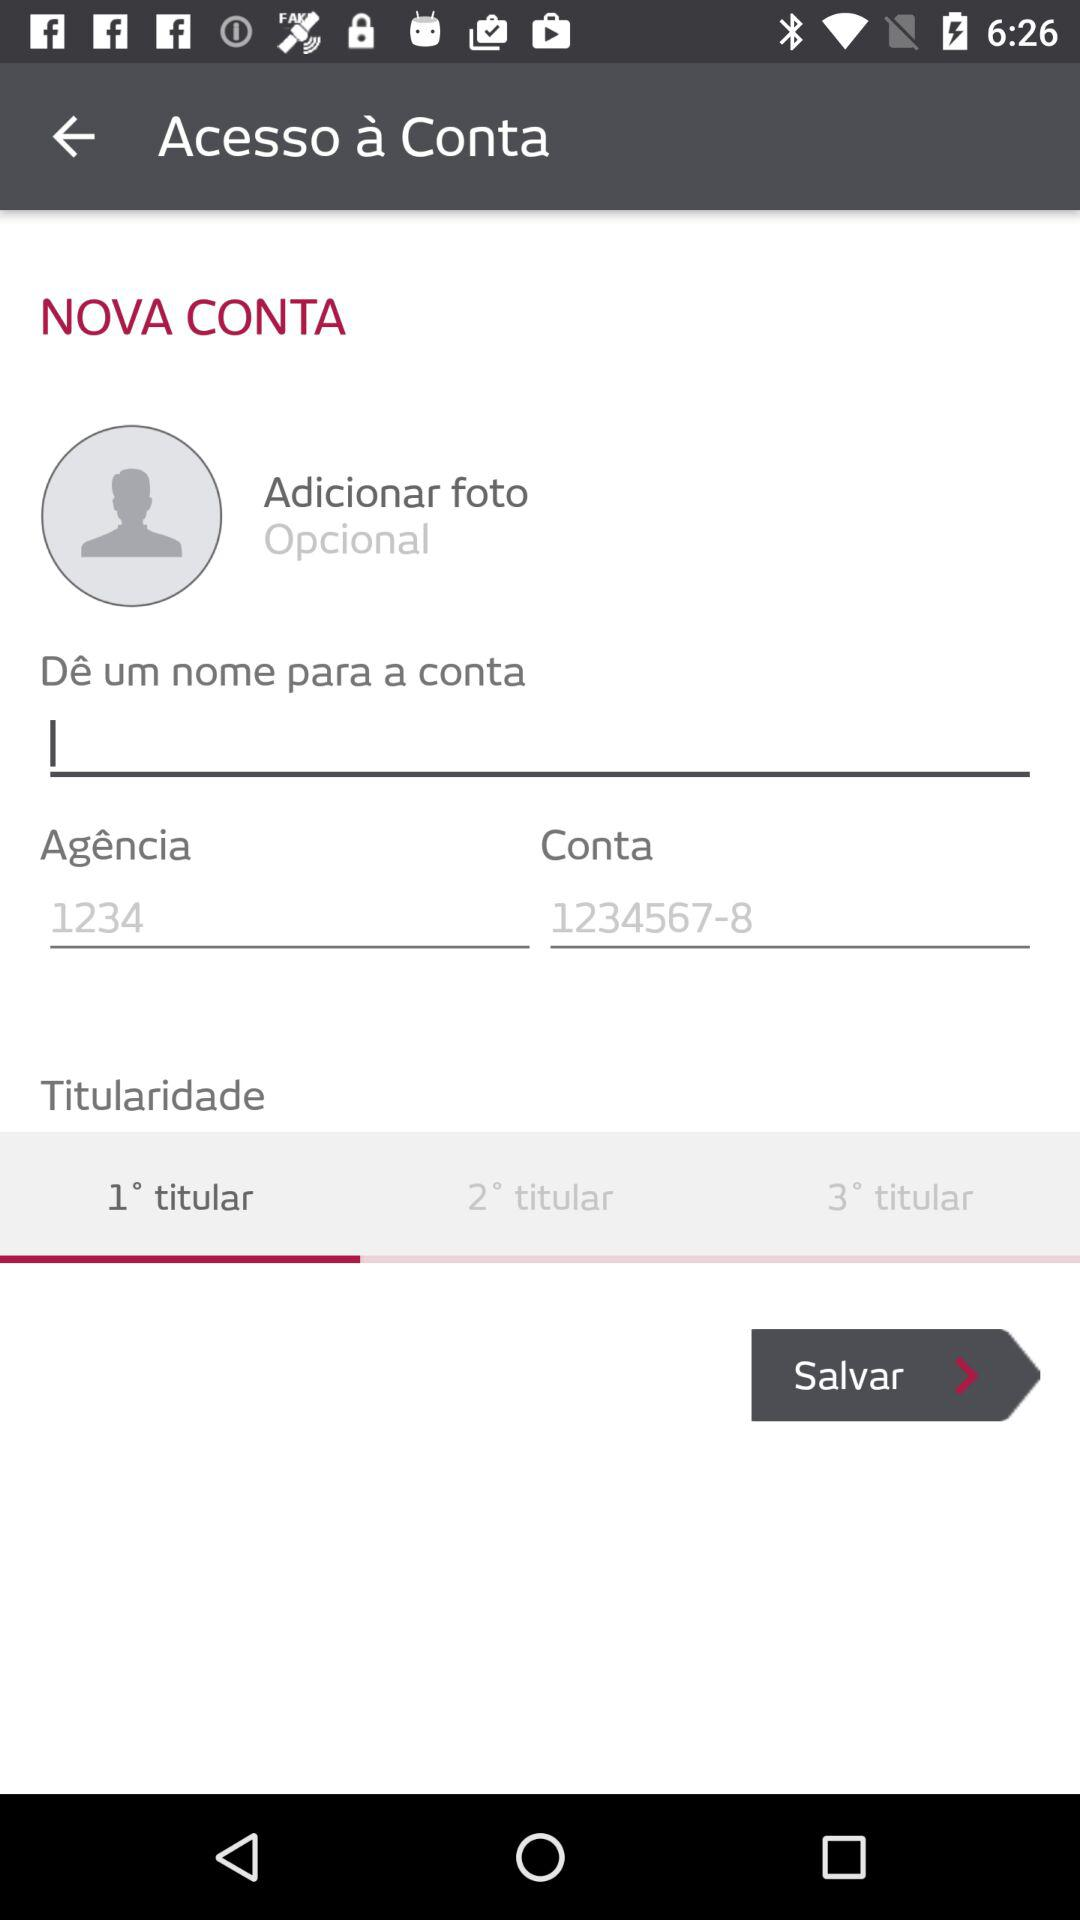How many text inputs are there for the account details?
Answer the question using a single word or phrase. 3 